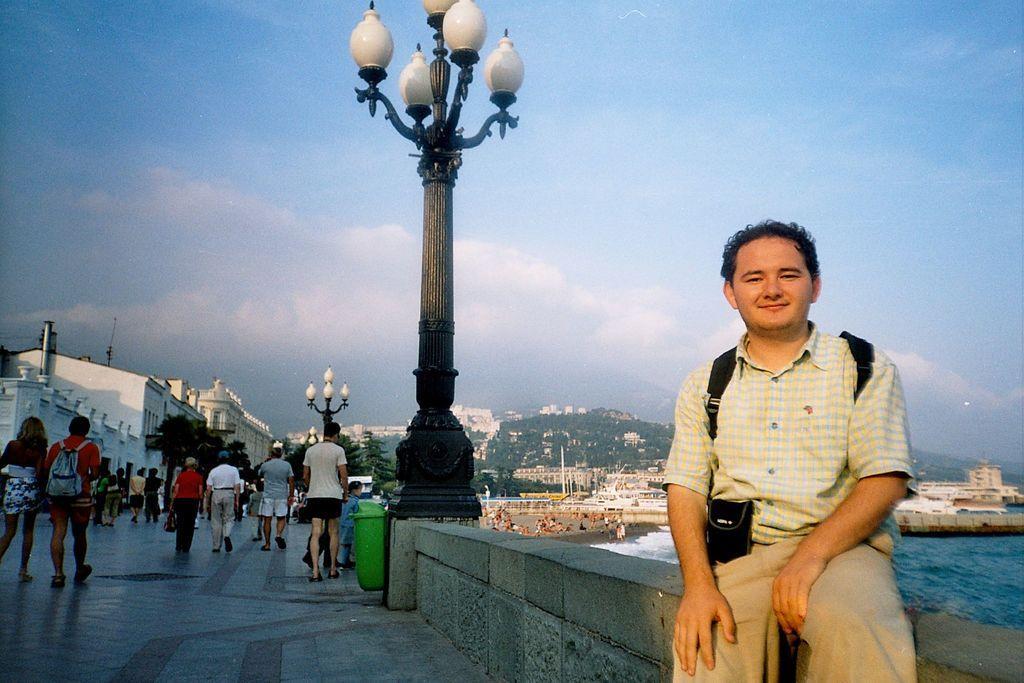In one or two sentences, can you explain what this image depicts? In this picture I can see few people walking and a man seated on the wall and I can see lights to the poles and I can see buildings and I can see few boats in the water and I can see trees on the hill and a blue cloudy sky. 